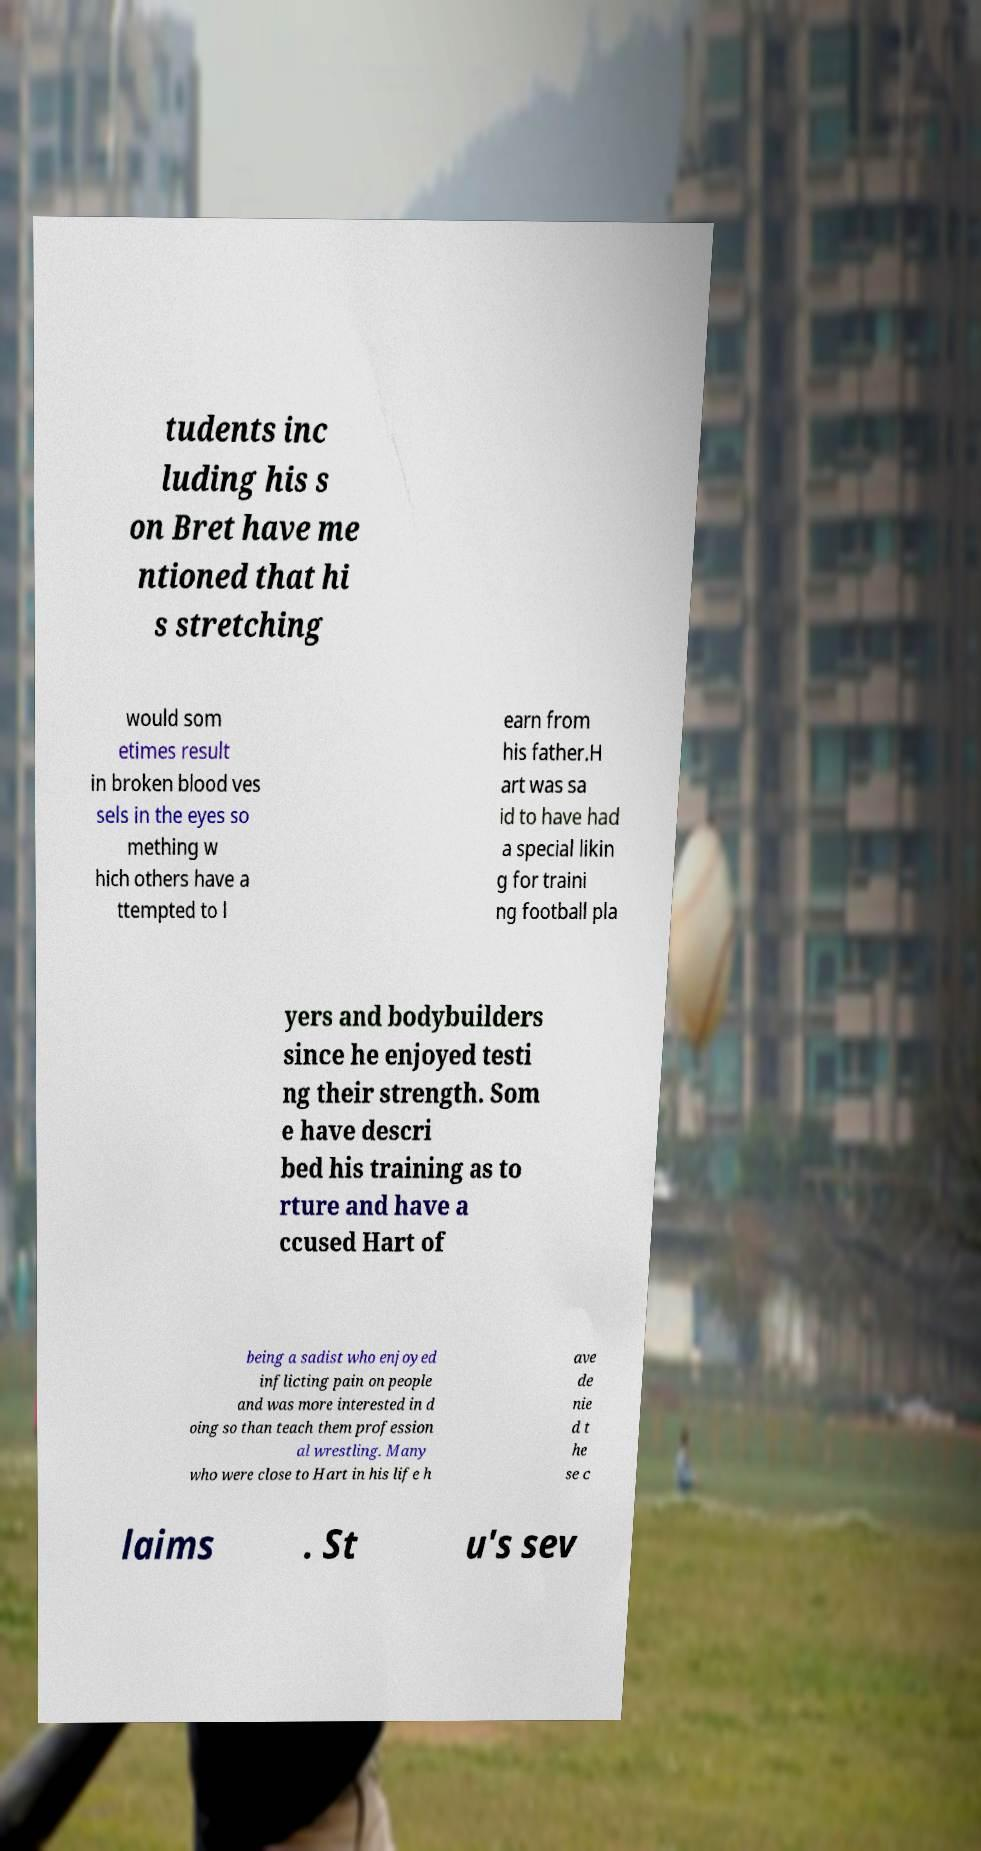I need the written content from this picture converted into text. Can you do that? tudents inc luding his s on Bret have me ntioned that hi s stretching would som etimes result in broken blood ves sels in the eyes so mething w hich others have a ttempted to l earn from his father.H art was sa id to have had a special likin g for traini ng football pla yers and bodybuilders since he enjoyed testi ng their strength. Som e have descri bed his training as to rture and have a ccused Hart of being a sadist who enjoyed inflicting pain on people and was more interested in d oing so than teach them profession al wrestling. Many who were close to Hart in his life h ave de nie d t he se c laims . St u's sev 